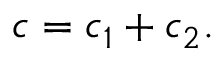<formula> <loc_0><loc_0><loc_500><loc_500>c = c _ { 1 } + c _ { 2 } .</formula> 